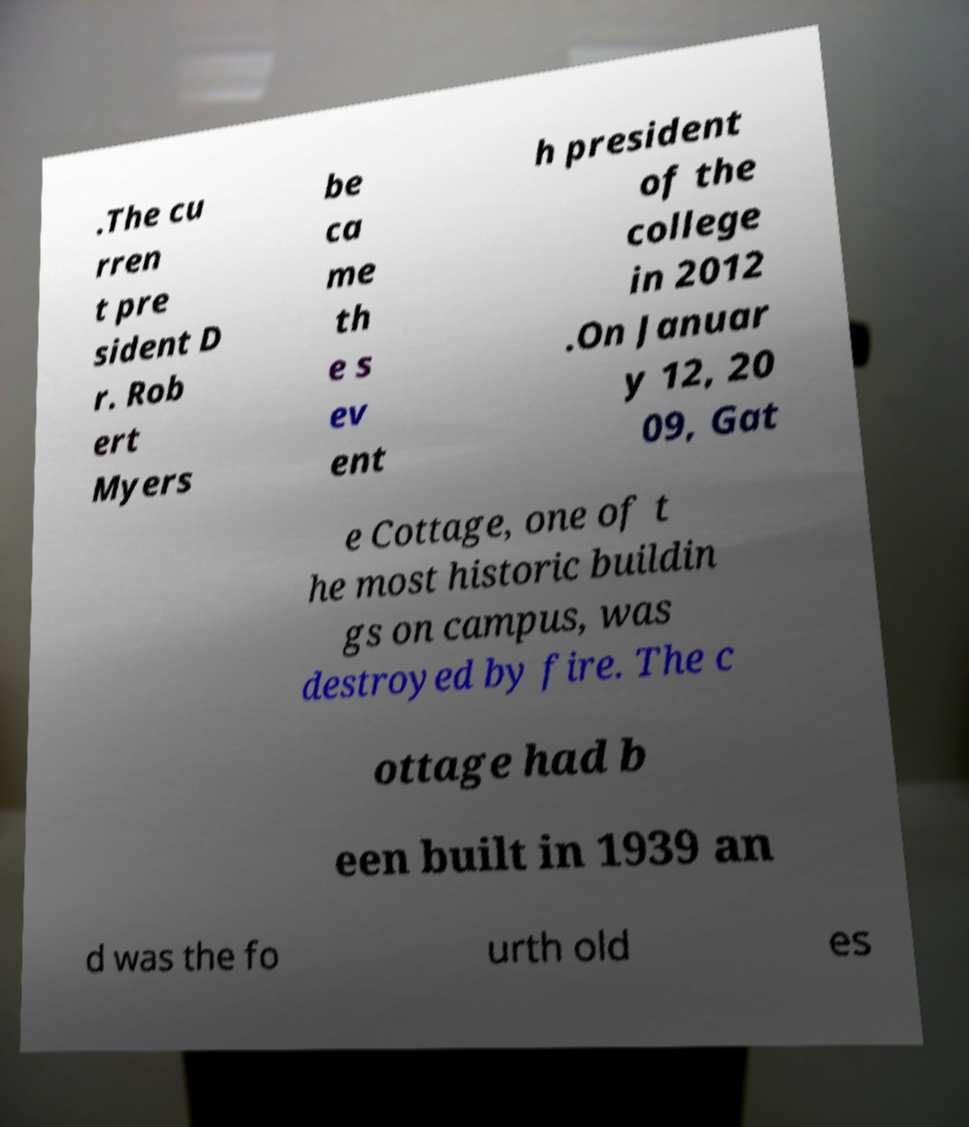I need the written content from this picture converted into text. Can you do that? .The cu rren t pre sident D r. Rob ert Myers be ca me th e s ev ent h president of the college in 2012 .On Januar y 12, 20 09, Gat e Cottage, one of t he most historic buildin gs on campus, was destroyed by fire. The c ottage had b een built in 1939 an d was the fo urth old es 